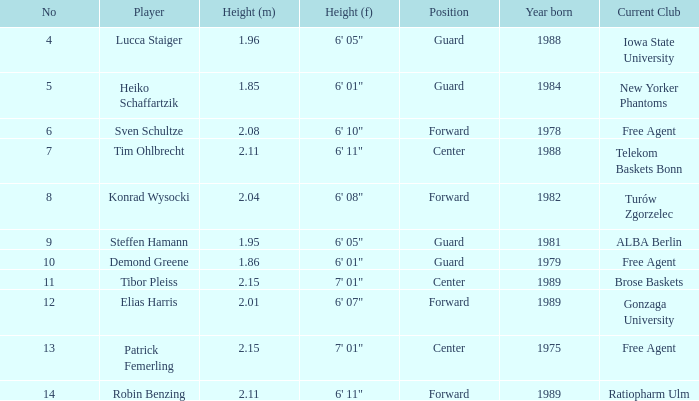Name the player that is 1.85 m Heiko Schaffartzik. 